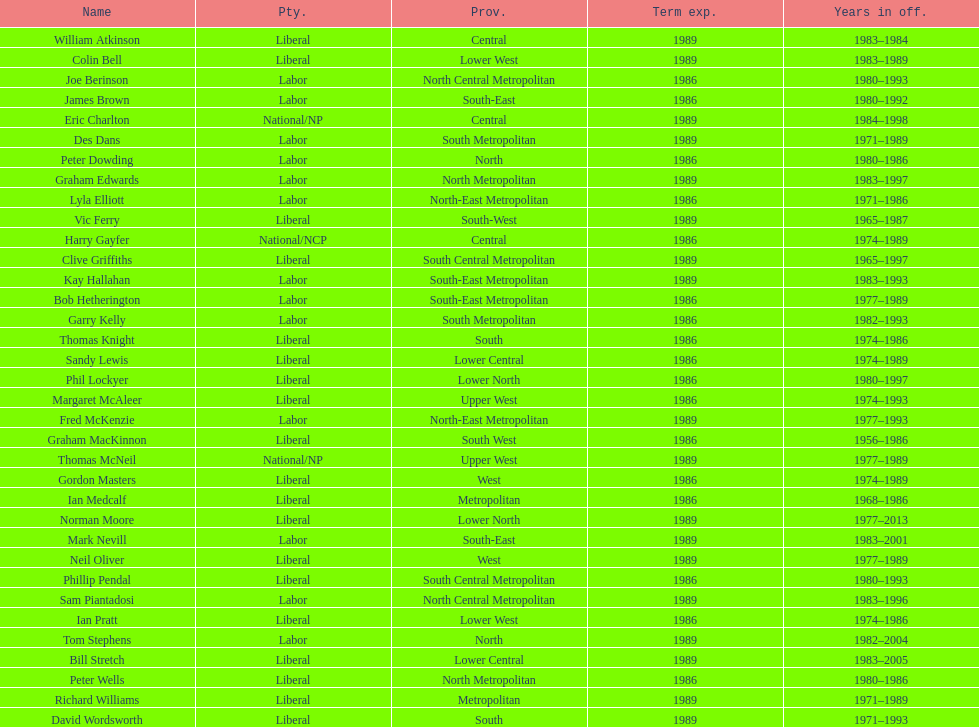What was phil lockyer's party? Liberal. 